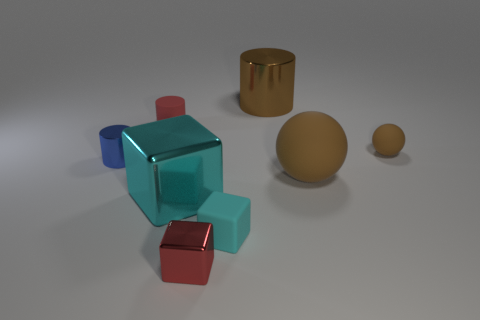Add 2 small matte blocks. How many objects exist? 10 Subtract all blocks. How many objects are left? 5 Add 1 metal things. How many metal things exist? 5 Subtract 1 brown balls. How many objects are left? 7 Subtract all tiny blue shiny things. Subtract all big matte spheres. How many objects are left? 6 Add 5 red things. How many red things are left? 7 